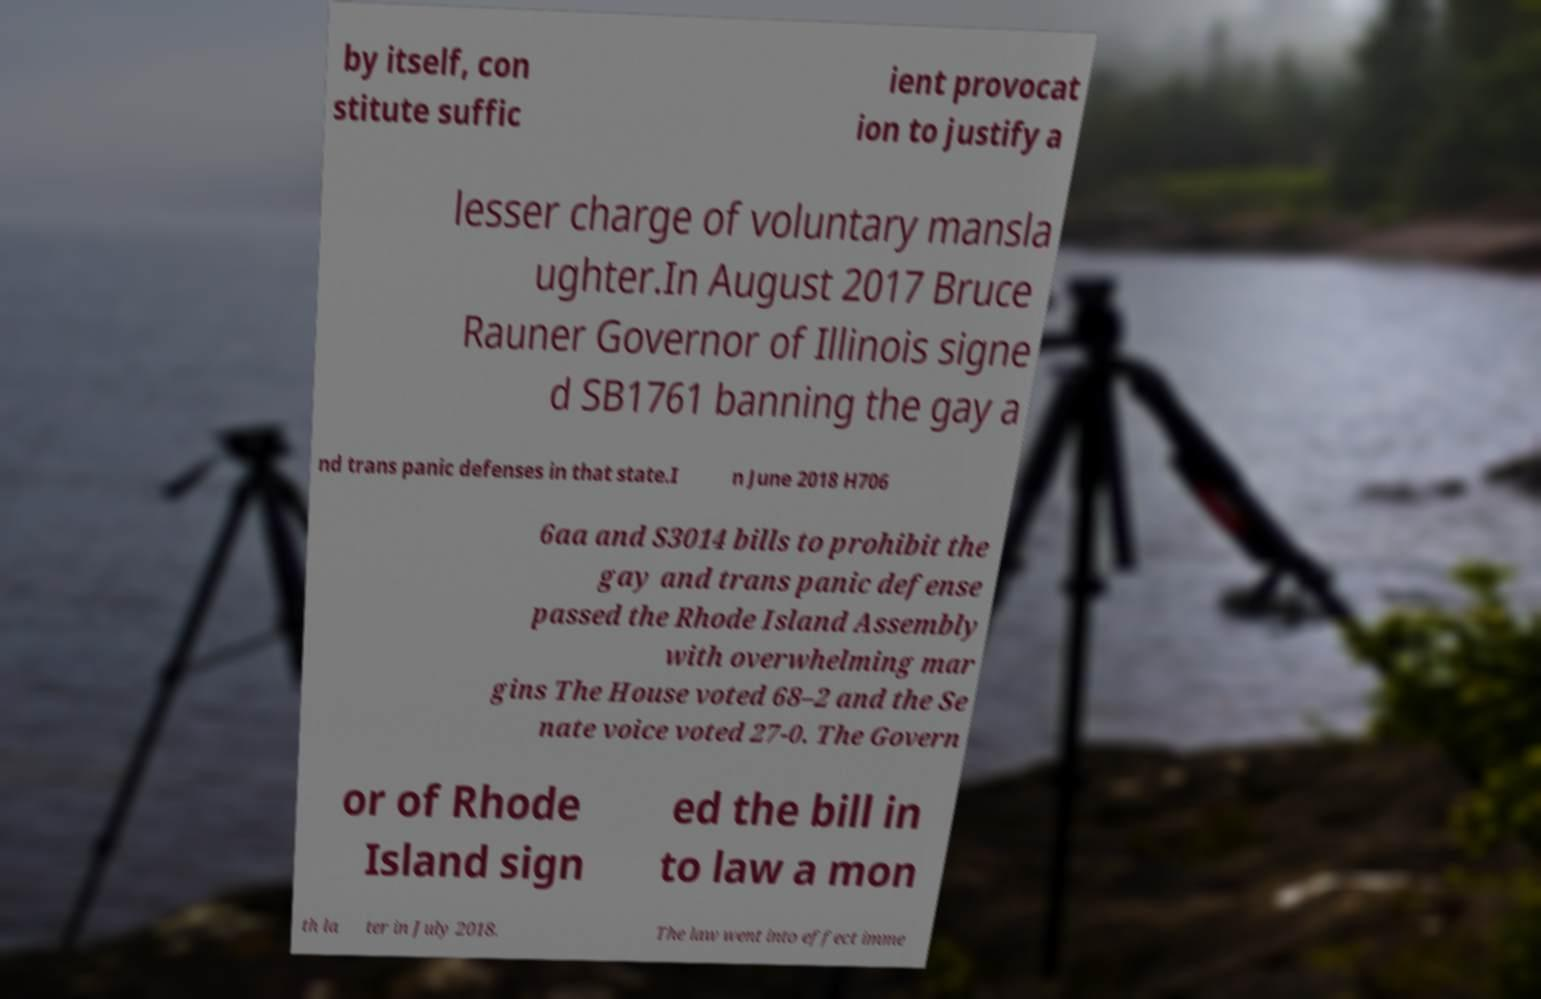Please identify and transcribe the text found in this image. by itself, con stitute suffic ient provocat ion to justify a lesser charge of voluntary mansla ughter.In August 2017 Bruce Rauner Governor of Illinois signe d SB1761 banning the gay a nd trans panic defenses in that state.I n June 2018 H706 6aa and S3014 bills to prohibit the gay and trans panic defense passed the Rhode Island Assembly with overwhelming mar gins The House voted 68–2 and the Se nate voice voted 27-0. The Govern or of Rhode Island sign ed the bill in to law a mon th la ter in July 2018. The law went into effect imme 